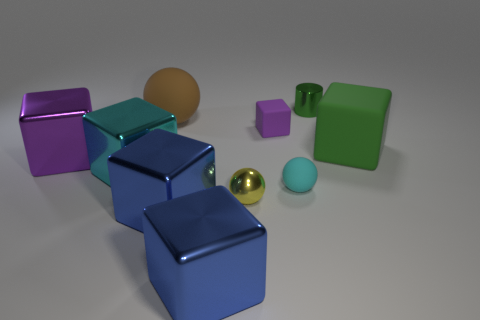There is a metallic thing that is behind the large purple metal cube; what shape is it?
Make the answer very short. Cylinder. Are there any yellow balls behind the large thing that is on the left side of the cyan metallic cube?
Keep it short and to the point. No. How many small yellow balls are the same material as the yellow thing?
Provide a short and direct response. 0. What size is the cyan object that is to the left of the matte sphere that is on the right side of the cube that is behind the green rubber object?
Your response must be concise. Large. How many small spheres are to the left of the tiny purple matte block?
Provide a short and direct response. 1. Is the number of big purple objects greater than the number of tiny rubber things?
Your answer should be compact. No. What size is the other metallic cube that is the same color as the small cube?
Your answer should be very brief. Large. There is a ball that is on the left side of the small cyan object and in front of the large cyan shiny object; what size is it?
Offer a terse response. Small. What material is the purple cube that is right of the purple cube that is left of the cyan object that is to the left of the large brown rubber ball?
Your answer should be very brief. Rubber. What material is the large object that is the same color as the tiny cube?
Keep it short and to the point. Metal. 